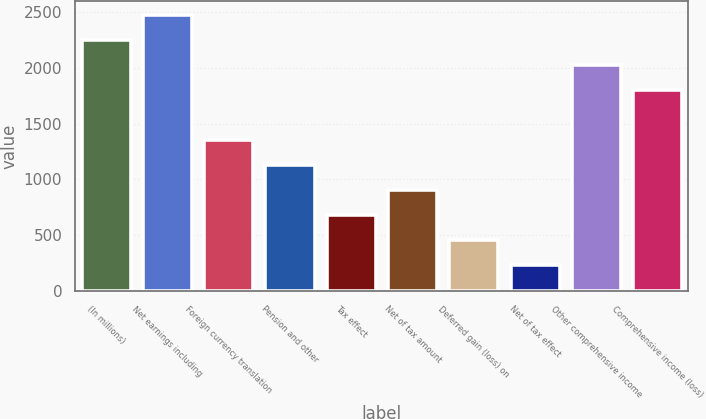Convert chart. <chart><loc_0><loc_0><loc_500><loc_500><bar_chart><fcel>(In millions)<fcel>Net earnings including<fcel>Foreign currency translation<fcel>Pension and other<fcel>Tax effect<fcel>Net of tax amount<fcel>Deferred gain (loss) on<fcel>Net of tax effect<fcel>Other comprehensive income<fcel>Comprehensive income (loss)<nl><fcel>2253<fcel>2477.9<fcel>1353.4<fcel>1128.5<fcel>678.7<fcel>903.6<fcel>453.8<fcel>228.9<fcel>2028.1<fcel>1803.2<nl></chart> 